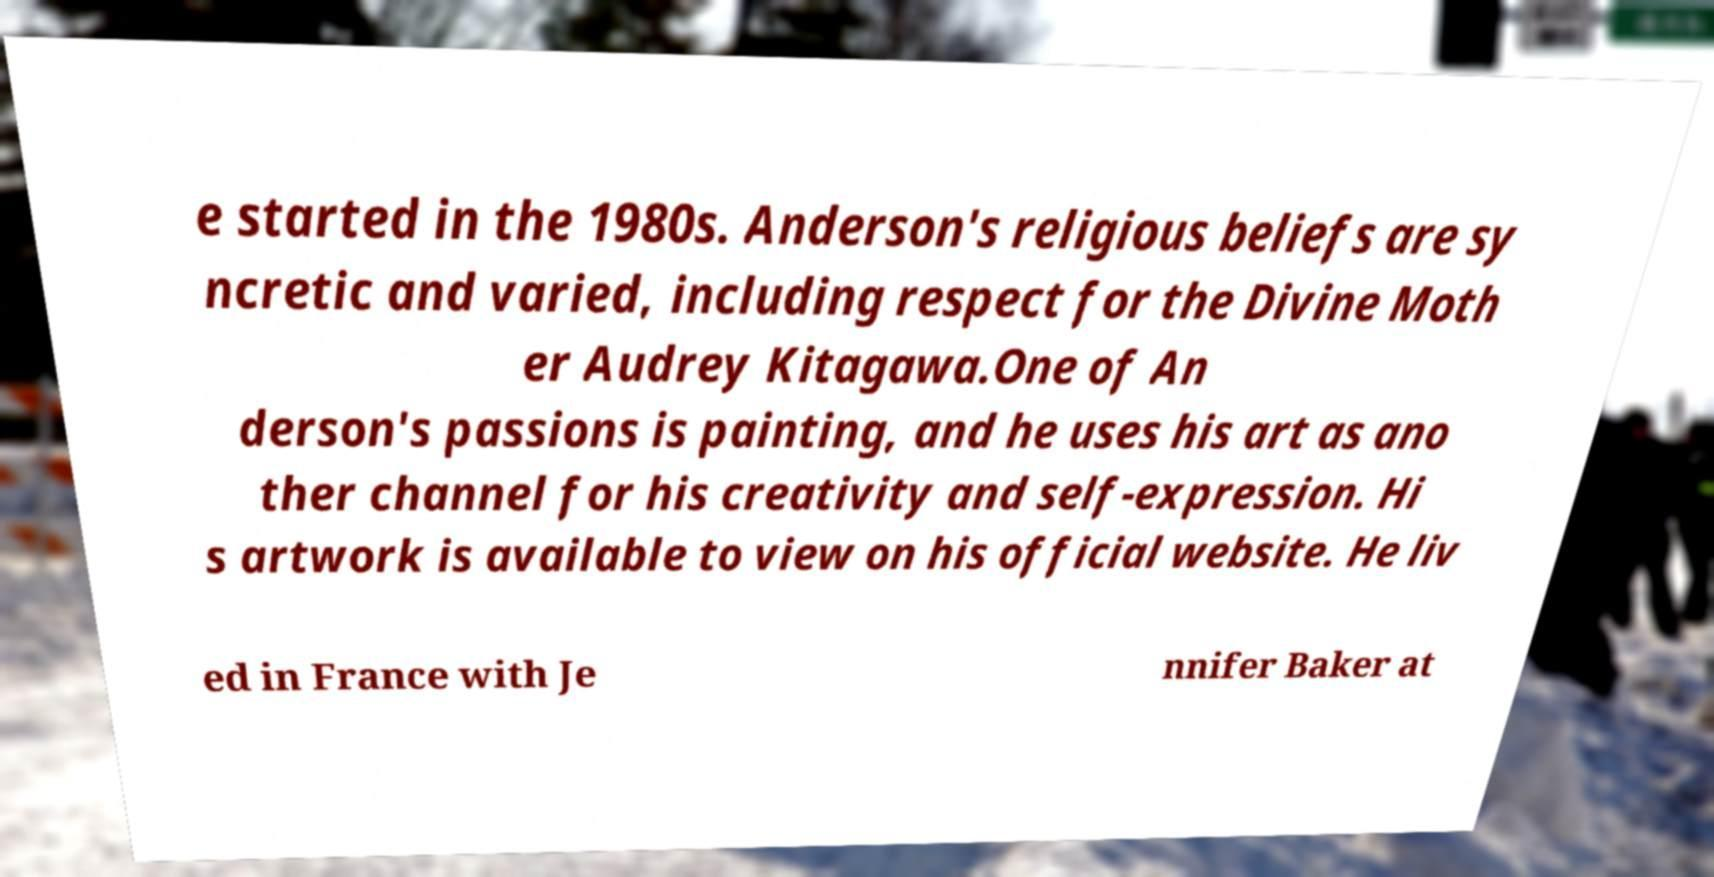Could you assist in decoding the text presented in this image and type it out clearly? e started in the 1980s. Anderson's religious beliefs are sy ncretic and varied, including respect for the Divine Moth er Audrey Kitagawa.One of An derson's passions is painting, and he uses his art as ano ther channel for his creativity and self-expression. Hi s artwork is available to view on his official website. He liv ed in France with Je nnifer Baker at 